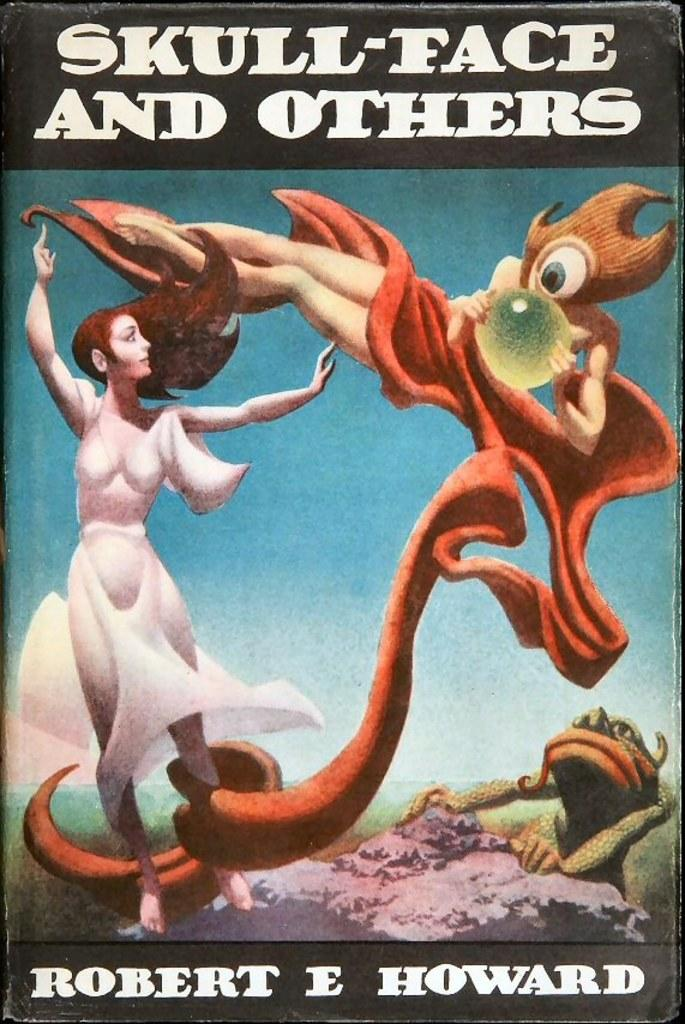<image>
Relay a brief, clear account of the picture shown. a poster with an animal and a woman and the word skull-face at the top 